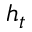<formula> <loc_0><loc_0><loc_500><loc_500>h _ { t }</formula> 